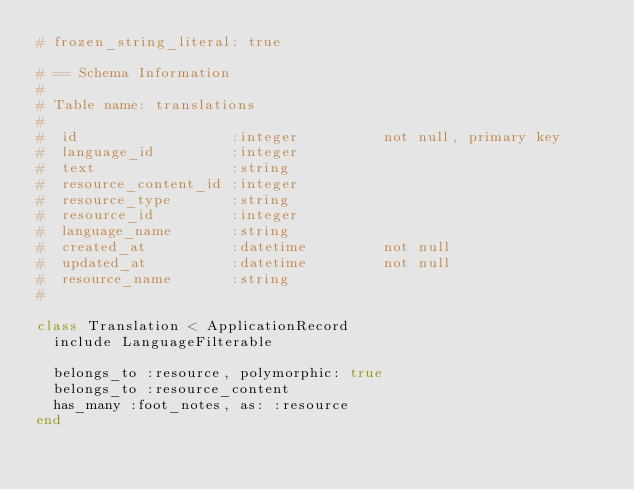Convert code to text. <code><loc_0><loc_0><loc_500><loc_500><_Ruby_># frozen_string_literal: true

# == Schema Information
#
# Table name: translations
#
#  id                  :integer          not null, primary key
#  language_id         :integer
#  text                :string
#  resource_content_id :integer
#  resource_type       :string
#  resource_id         :integer
#  language_name       :string
#  created_at          :datetime         not null
#  updated_at          :datetime         not null
#  resource_name       :string
#

class Translation < ApplicationRecord
  include LanguageFilterable

  belongs_to :resource, polymorphic: true
  belongs_to :resource_content
  has_many :foot_notes, as: :resource
end
</code> 